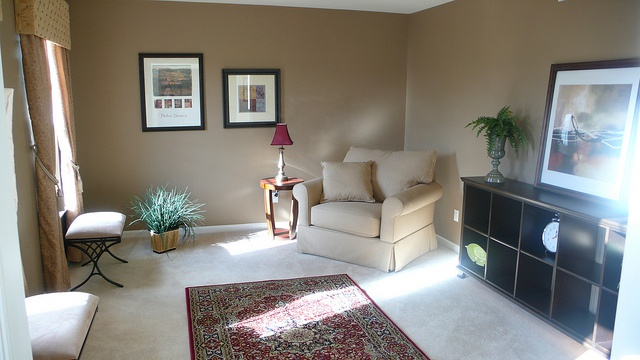Describe the objects in this image and their specific colors. I can see couch in olive, darkgray, lightgray, and gray tones, chair in olive, darkgray, lightgray, and gray tones, chair in olive, white, darkgray, and gray tones, bench in olive, white, darkgray, and gray tones, and potted plant in olive, gray, darkgray, and teal tones in this image. 